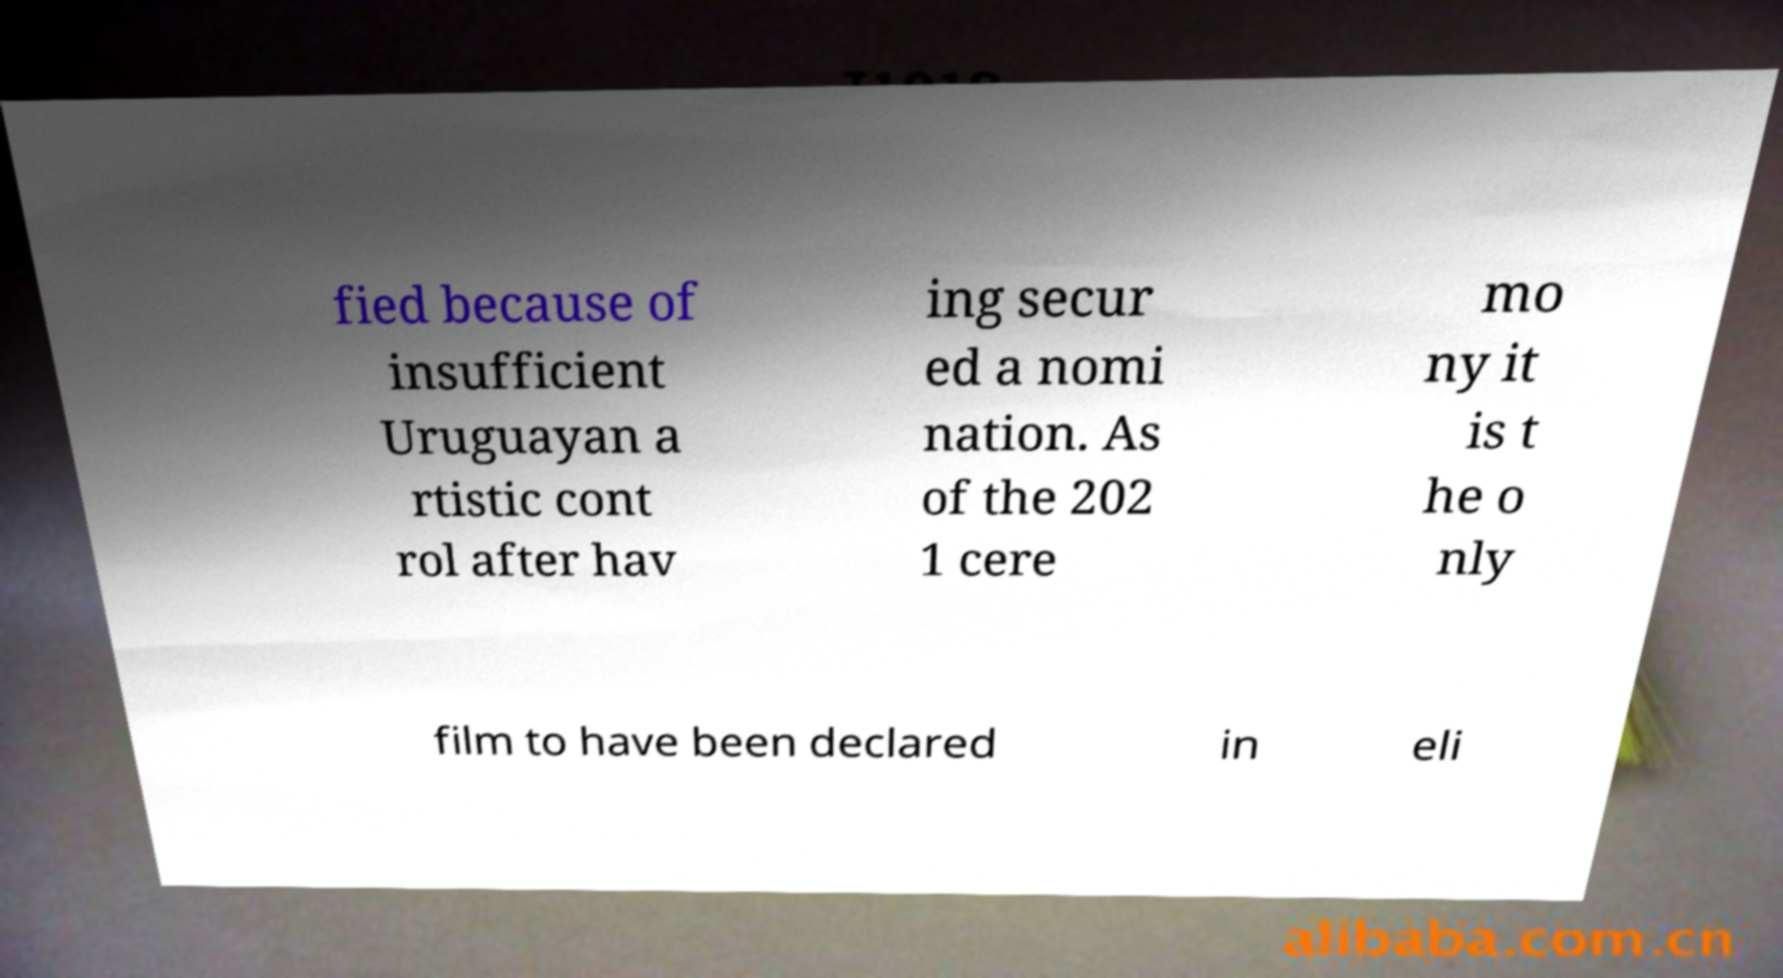Please identify and transcribe the text found in this image. fied because of insufficient Uruguayan a rtistic cont rol after hav ing secur ed a nomi nation. As of the 202 1 cere mo ny it is t he o nly film to have been declared in eli 